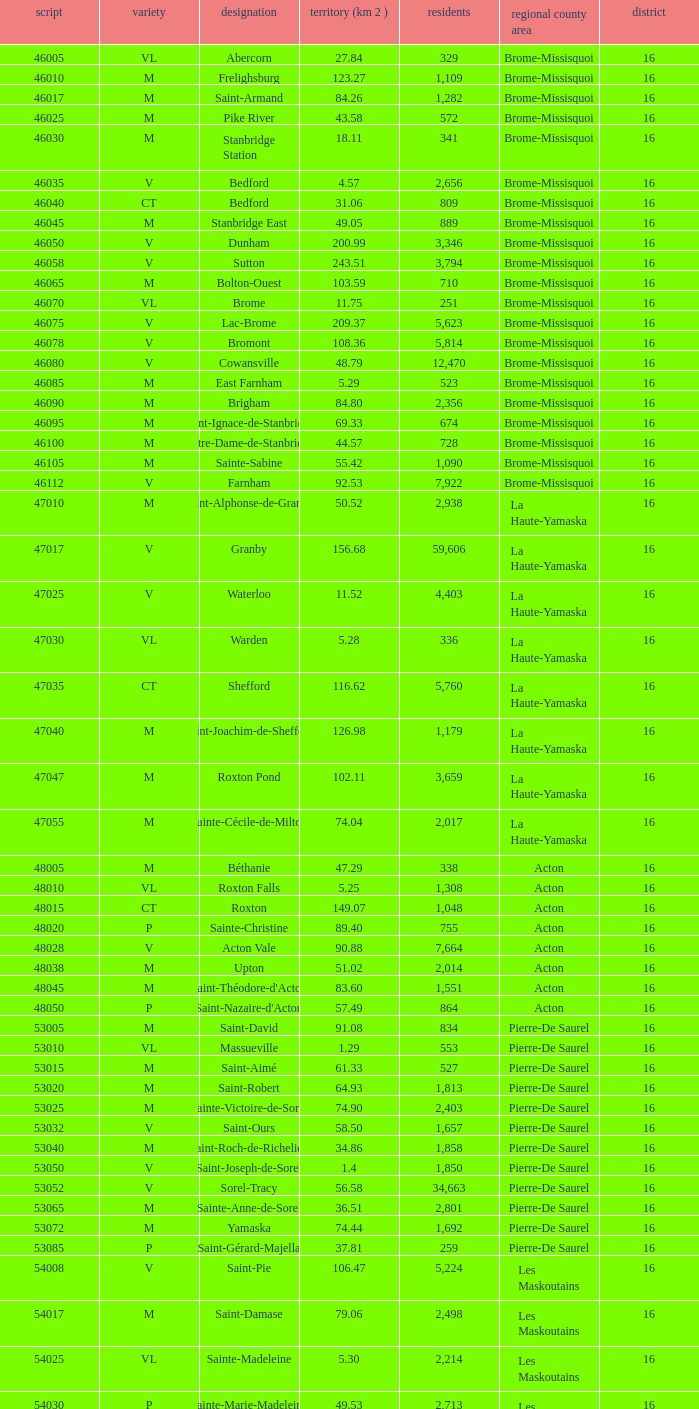Cowansville has less than 16 regions and is a Brome-Missisquoi Municipality, what is their population? None. 